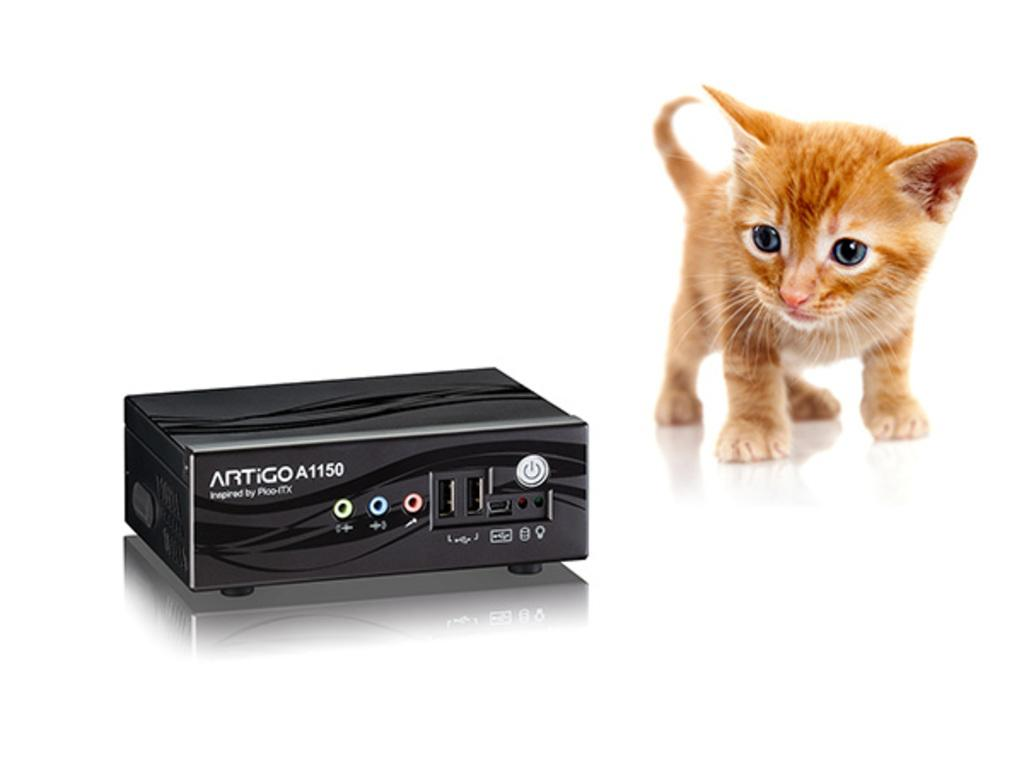What is the color of the device in the image? The device is black in color. Where is the device located in the image? The device is placed on a surface. What can be seen on the right side of the image? There is a kitten on the right side of the image. What is the background of the image? There is a white backdrop in the image. What type of texture can be observed on the kitten's fur in the image? There is no information about the texture of the kitten's fur in the image. 